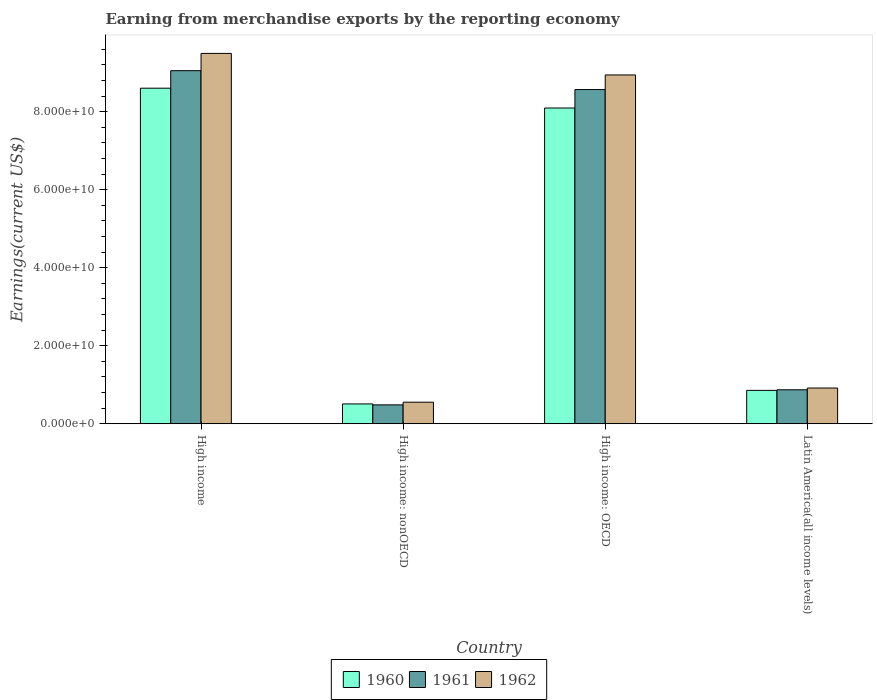How many different coloured bars are there?
Give a very brief answer. 3. How many groups of bars are there?
Ensure brevity in your answer.  4. Are the number of bars on each tick of the X-axis equal?
Offer a very short reply. Yes. How many bars are there on the 2nd tick from the right?
Ensure brevity in your answer.  3. What is the label of the 2nd group of bars from the left?
Keep it short and to the point. High income: nonOECD. What is the amount earned from merchandise exports in 1961 in Latin America(all income levels)?
Make the answer very short. 8.70e+09. Across all countries, what is the maximum amount earned from merchandise exports in 1961?
Your answer should be compact. 9.05e+1. Across all countries, what is the minimum amount earned from merchandise exports in 1961?
Offer a terse response. 4.84e+09. In which country was the amount earned from merchandise exports in 1962 minimum?
Keep it short and to the point. High income: nonOECD. What is the total amount earned from merchandise exports in 1961 in the graph?
Keep it short and to the point. 1.90e+11. What is the difference between the amount earned from merchandise exports in 1962 in High income: OECD and that in High income: nonOECD?
Offer a terse response. 8.39e+1. What is the difference between the amount earned from merchandise exports in 1960 in High income: nonOECD and the amount earned from merchandise exports in 1961 in High income?
Offer a terse response. -8.54e+1. What is the average amount earned from merchandise exports in 1960 per country?
Provide a short and direct response. 4.52e+1. What is the difference between the amount earned from merchandise exports of/in 1962 and amount earned from merchandise exports of/in 1960 in Latin America(all income levels)?
Make the answer very short. 6.04e+08. In how many countries, is the amount earned from merchandise exports in 1962 greater than 4000000000 US$?
Ensure brevity in your answer.  4. What is the ratio of the amount earned from merchandise exports in 1962 in High income: nonOECD to that in Latin America(all income levels)?
Provide a short and direct response. 0.6. Is the difference between the amount earned from merchandise exports in 1962 in High income: OECD and Latin America(all income levels) greater than the difference between the amount earned from merchandise exports in 1960 in High income: OECD and Latin America(all income levels)?
Provide a short and direct response. Yes. What is the difference between the highest and the second highest amount earned from merchandise exports in 1962?
Provide a short and direct response. 8.58e+1. What is the difference between the highest and the lowest amount earned from merchandise exports in 1962?
Ensure brevity in your answer.  8.94e+1. Is the sum of the amount earned from merchandise exports in 1961 in High income: OECD and High income: nonOECD greater than the maximum amount earned from merchandise exports in 1960 across all countries?
Offer a very short reply. Yes. What does the 1st bar from the left in High income: OECD represents?
Your answer should be very brief. 1960. What does the 2nd bar from the right in High income: nonOECD represents?
Make the answer very short. 1961. What is the difference between two consecutive major ticks on the Y-axis?
Make the answer very short. 2.00e+1. How are the legend labels stacked?
Offer a terse response. Horizontal. What is the title of the graph?
Ensure brevity in your answer.  Earning from merchandise exports by the reporting economy. What is the label or title of the Y-axis?
Your answer should be compact. Earnings(current US$). What is the Earnings(current US$) in 1960 in High income?
Ensure brevity in your answer.  8.60e+1. What is the Earnings(current US$) in 1961 in High income?
Your answer should be compact. 9.05e+1. What is the Earnings(current US$) of 1962 in High income?
Offer a very short reply. 9.49e+1. What is the Earnings(current US$) in 1960 in High income: nonOECD?
Keep it short and to the point. 5.08e+09. What is the Earnings(current US$) in 1961 in High income: nonOECD?
Your answer should be very brief. 4.84e+09. What is the Earnings(current US$) in 1962 in High income: nonOECD?
Offer a terse response. 5.53e+09. What is the Earnings(current US$) in 1960 in High income: OECD?
Your answer should be compact. 8.09e+1. What is the Earnings(current US$) of 1961 in High income: OECD?
Offer a very short reply. 8.57e+1. What is the Earnings(current US$) of 1962 in High income: OECD?
Ensure brevity in your answer.  8.94e+1. What is the Earnings(current US$) of 1960 in Latin America(all income levels)?
Give a very brief answer. 8.55e+09. What is the Earnings(current US$) of 1961 in Latin America(all income levels)?
Your answer should be compact. 8.70e+09. What is the Earnings(current US$) in 1962 in Latin America(all income levels)?
Make the answer very short. 9.15e+09. Across all countries, what is the maximum Earnings(current US$) of 1960?
Offer a terse response. 8.60e+1. Across all countries, what is the maximum Earnings(current US$) in 1961?
Ensure brevity in your answer.  9.05e+1. Across all countries, what is the maximum Earnings(current US$) of 1962?
Your answer should be very brief. 9.49e+1. Across all countries, what is the minimum Earnings(current US$) in 1960?
Make the answer very short. 5.08e+09. Across all countries, what is the minimum Earnings(current US$) in 1961?
Offer a terse response. 4.84e+09. Across all countries, what is the minimum Earnings(current US$) in 1962?
Your answer should be very brief. 5.53e+09. What is the total Earnings(current US$) in 1960 in the graph?
Your answer should be very brief. 1.81e+11. What is the total Earnings(current US$) in 1961 in the graph?
Your answer should be compact. 1.90e+11. What is the total Earnings(current US$) of 1962 in the graph?
Provide a short and direct response. 1.99e+11. What is the difference between the Earnings(current US$) in 1960 in High income and that in High income: nonOECD?
Give a very brief answer. 8.09e+1. What is the difference between the Earnings(current US$) in 1961 in High income and that in High income: nonOECD?
Give a very brief answer. 8.57e+1. What is the difference between the Earnings(current US$) of 1962 in High income and that in High income: nonOECD?
Provide a succinct answer. 8.94e+1. What is the difference between the Earnings(current US$) in 1960 in High income and that in High income: OECD?
Your response must be concise. 5.08e+09. What is the difference between the Earnings(current US$) in 1961 in High income and that in High income: OECD?
Give a very brief answer. 4.84e+09. What is the difference between the Earnings(current US$) of 1962 in High income and that in High income: OECD?
Offer a terse response. 5.53e+09. What is the difference between the Earnings(current US$) of 1960 in High income and that in Latin America(all income levels)?
Provide a short and direct response. 7.75e+1. What is the difference between the Earnings(current US$) in 1961 in High income and that in Latin America(all income levels)?
Offer a very short reply. 8.18e+1. What is the difference between the Earnings(current US$) in 1962 in High income and that in Latin America(all income levels)?
Offer a very short reply. 8.58e+1. What is the difference between the Earnings(current US$) of 1960 in High income: nonOECD and that in High income: OECD?
Offer a very short reply. -7.59e+1. What is the difference between the Earnings(current US$) in 1961 in High income: nonOECD and that in High income: OECD?
Offer a terse response. -8.08e+1. What is the difference between the Earnings(current US$) of 1962 in High income: nonOECD and that in High income: OECD?
Offer a very short reply. -8.39e+1. What is the difference between the Earnings(current US$) of 1960 in High income: nonOECD and that in Latin America(all income levels)?
Ensure brevity in your answer.  -3.47e+09. What is the difference between the Earnings(current US$) in 1961 in High income: nonOECD and that in Latin America(all income levels)?
Offer a very short reply. -3.86e+09. What is the difference between the Earnings(current US$) in 1962 in High income: nonOECD and that in Latin America(all income levels)?
Offer a very short reply. -3.63e+09. What is the difference between the Earnings(current US$) in 1960 in High income: OECD and that in Latin America(all income levels)?
Give a very brief answer. 7.24e+1. What is the difference between the Earnings(current US$) of 1961 in High income: OECD and that in Latin America(all income levels)?
Your answer should be very brief. 7.70e+1. What is the difference between the Earnings(current US$) in 1962 in High income: OECD and that in Latin America(all income levels)?
Offer a very short reply. 8.03e+1. What is the difference between the Earnings(current US$) in 1960 in High income and the Earnings(current US$) in 1961 in High income: nonOECD?
Ensure brevity in your answer.  8.12e+1. What is the difference between the Earnings(current US$) of 1960 in High income and the Earnings(current US$) of 1962 in High income: nonOECD?
Offer a terse response. 8.05e+1. What is the difference between the Earnings(current US$) of 1961 in High income and the Earnings(current US$) of 1962 in High income: nonOECD?
Your answer should be very brief. 8.50e+1. What is the difference between the Earnings(current US$) in 1960 in High income and the Earnings(current US$) in 1961 in High income: OECD?
Your response must be concise. 3.49e+08. What is the difference between the Earnings(current US$) of 1960 in High income and the Earnings(current US$) of 1962 in High income: OECD?
Offer a terse response. -3.39e+09. What is the difference between the Earnings(current US$) in 1961 in High income and the Earnings(current US$) in 1962 in High income: OECD?
Keep it short and to the point. 1.10e+09. What is the difference between the Earnings(current US$) in 1960 in High income and the Earnings(current US$) in 1961 in Latin America(all income levels)?
Offer a terse response. 7.73e+1. What is the difference between the Earnings(current US$) in 1960 in High income and the Earnings(current US$) in 1962 in Latin America(all income levels)?
Provide a succinct answer. 7.69e+1. What is the difference between the Earnings(current US$) in 1961 in High income and the Earnings(current US$) in 1962 in Latin America(all income levels)?
Make the answer very short. 8.14e+1. What is the difference between the Earnings(current US$) in 1960 in High income: nonOECD and the Earnings(current US$) in 1961 in High income: OECD?
Give a very brief answer. -8.06e+1. What is the difference between the Earnings(current US$) in 1960 in High income: nonOECD and the Earnings(current US$) in 1962 in High income: OECD?
Offer a terse response. -8.43e+1. What is the difference between the Earnings(current US$) of 1961 in High income: nonOECD and the Earnings(current US$) of 1962 in High income: OECD?
Make the answer very short. -8.46e+1. What is the difference between the Earnings(current US$) in 1960 in High income: nonOECD and the Earnings(current US$) in 1961 in Latin America(all income levels)?
Offer a very short reply. -3.63e+09. What is the difference between the Earnings(current US$) in 1960 in High income: nonOECD and the Earnings(current US$) in 1962 in Latin America(all income levels)?
Ensure brevity in your answer.  -4.08e+09. What is the difference between the Earnings(current US$) in 1961 in High income: nonOECD and the Earnings(current US$) in 1962 in Latin America(all income levels)?
Ensure brevity in your answer.  -4.31e+09. What is the difference between the Earnings(current US$) in 1960 in High income: OECD and the Earnings(current US$) in 1961 in Latin America(all income levels)?
Make the answer very short. 7.22e+1. What is the difference between the Earnings(current US$) in 1960 in High income: OECD and the Earnings(current US$) in 1962 in Latin America(all income levels)?
Offer a terse response. 7.18e+1. What is the difference between the Earnings(current US$) of 1961 in High income: OECD and the Earnings(current US$) of 1962 in Latin America(all income levels)?
Provide a succinct answer. 7.65e+1. What is the average Earnings(current US$) of 1960 per country?
Your answer should be compact. 4.52e+1. What is the average Earnings(current US$) in 1961 per country?
Ensure brevity in your answer.  4.74e+1. What is the average Earnings(current US$) in 1962 per country?
Give a very brief answer. 4.98e+1. What is the difference between the Earnings(current US$) of 1960 and Earnings(current US$) of 1961 in High income?
Your answer should be compact. -4.49e+09. What is the difference between the Earnings(current US$) of 1960 and Earnings(current US$) of 1962 in High income?
Provide a succinct answer. -8.92e+09. What is the difference between the Earnings(current US$) in 1961 and Earnings(current US$) in 1962 in High income?
Your response must be concise. -4.43e+09. What is the difference between the Earnings(current US$) of 1960 and Earnings(current US$) of 1961 in High income: nonOECD?
Provide a short and direct response. 2.39e+08. What is the difference between the Earnings(current US$) in 1960 and Earnings(current US$) in 1962 in High income: nonOECD?
Provide a short and direct response. -4.48e+08. What is the difference between the Earnings(current US$) of 1961 and Earnings(current US$) of 1962 in High income: nonOECD?
Your response must be concise. -6.87e+08. What is the difference between the Earnings(current US$) in 1960 and Earnings(current US$) in 1961 in High income: OECD?
Keep it short and to the point. -4.73e+09. What is the difference between the Earnings(current US$) in 1960 and Earnings(current US$) in 1962 in High income: OECD?
Offer a very short reply. -8.47e+09. What is the difference between the Earnings(current US$) in 1961 and Earnings(current US$) in 1962 in High income: OECD?
Offer a very short reply. -3.74e+09. What is the difference between the Earnings(current US$) in 1960 and Earnings(current US$) in 1961 in Latin America(all income levels)?
Keep it short and to the point. -1.53e+08. What is the difference between the Earnings(current US$) of 1960 and Earnings(current US$) of 1962 in Latin America(all income levels)?
Offer a very short reply. -6.04e+08. What is the difference between the Earnings(current US$) in 1961 and Earnings(current US$) in 1962 in Latin America(all income levels)?
Your response must be concise. -4.50e+08. What is the ratio of the Earnings(current US$) of 1960 in High income to that in High income: nonOECD?
Your answer should be very brief. 16.94. What is the ratio of the Earnings(current US$) in 1961 in High income to that in High income: nonOECD?
Your answer should be very brief. 18.7. What is the ratio of the Earnings(current US$) in 1962 in High income to that in High income: nonOECD?
Offer a terse response. 17.18. What is the ratio of the Earnings(current US$) of 1960 in High income to that in High income: OECD?
Offer a terse response. 1.06. What is the ratio of the Earnings(current US$) of 1961 in High income to that in High income: OECD?
Give a very brief answer. 1.06. What is the ratio of the Earnings(current US$) of 1962 in High income to that in High income: OECD?
Keep it short and to the point. 1.06. What is the ratio of the Earnings(current US$) of 1960 in High income to that in Latin America(all income levels)?
Your response must be concise. 10.06. What is the ratio of the Earnings(current US$) of 1961 in High income to that in Latin America(all income levels)?
Make the answer very short. 10.4. What is the ratio of the Earnings(current US$) in 1962 in High income to that in Latin America(all income levels)?
Provide a succinct answer. 10.37. What is the ratio of the Earnings(current US$) in 1960 in High income: nonOECD to that in High income: OECD?
Offer a terse response. 0.06. What is the ratio of the Earnings(current US$) of 1961 in High income: nonOECD to that in High income: OECD?
Keep it short and to the point. 0.06. What is the ratio of the Earnings(current US$) in 1962 in High income: nonOECD to that in High income: OECD?
Make the answer very short. 0.06. What is the ratio of the Earnings(current US$) of 1960 in High income: nonOECD to that in Latin America(all income levels)?
Provide a succinct answer. 0.59. What is the ratio of the Earnings(current US$) in 1961 in High income: nonOECD to that in Latin America(all income levels)?
Give a very brief answer. 0.56. What is the ratio of the Earnings(current US$) of 1962 in High income: nonOECD to that in Latin America(all income levels)?
Offer a very short reply. 0.6. What is the ratio of the Earnings(current US$) of 1960 in High income: OECD to that in Latin America(all income levels)?
Your answer should be compact. 9.47. What is the ratio of the Earnings(current US$) of 1961 in High income: OECD to that in Latin America(all income levels)?
Your response must be concise. 9.84. What is the ratio of the Earnings(current US$) of 1962 in High income: OECD to that in Latin America(all income levels)?
Your answer should be compact. 9.77. What is the difference between the highest and the second highest Earnings(current US$) of 1960?
Offer a terse response. 5.08e+09. What is the difference between the highest and the second highest Earnings(current US$) in 1961?
Give a very brief answer. 4.84e+09. What is the difference between the highest and the second highest Earnings(current US$) in 1962?
Ensure brevity in your answer.  5.53e+09. What is the difference between the highest and the lowest Earnings(current US$) of 1960?
Offer a very short reply. 8.09e+1. What is the difference between the highest and the lowest Earnings(current US$) of 1961?
Give a very brief answer. 8.57e+1. What is the difference between the highest and the lowest Earnings(current US$) of 1962?
Give a very brief answer. 8.94e+1. 